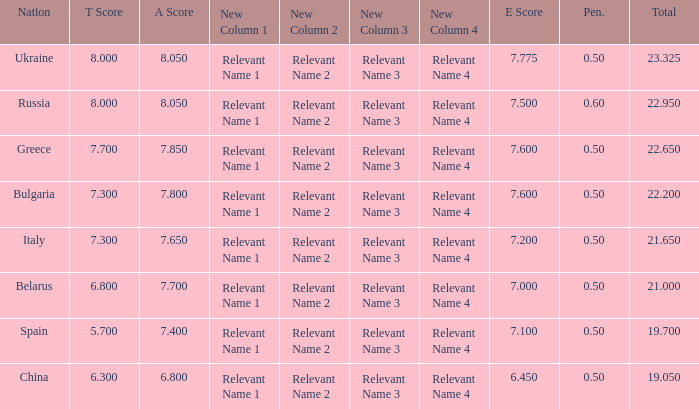What's the sum of A Score that also has a score lower than 7.3 and an E Score larger than 7.1? None. 